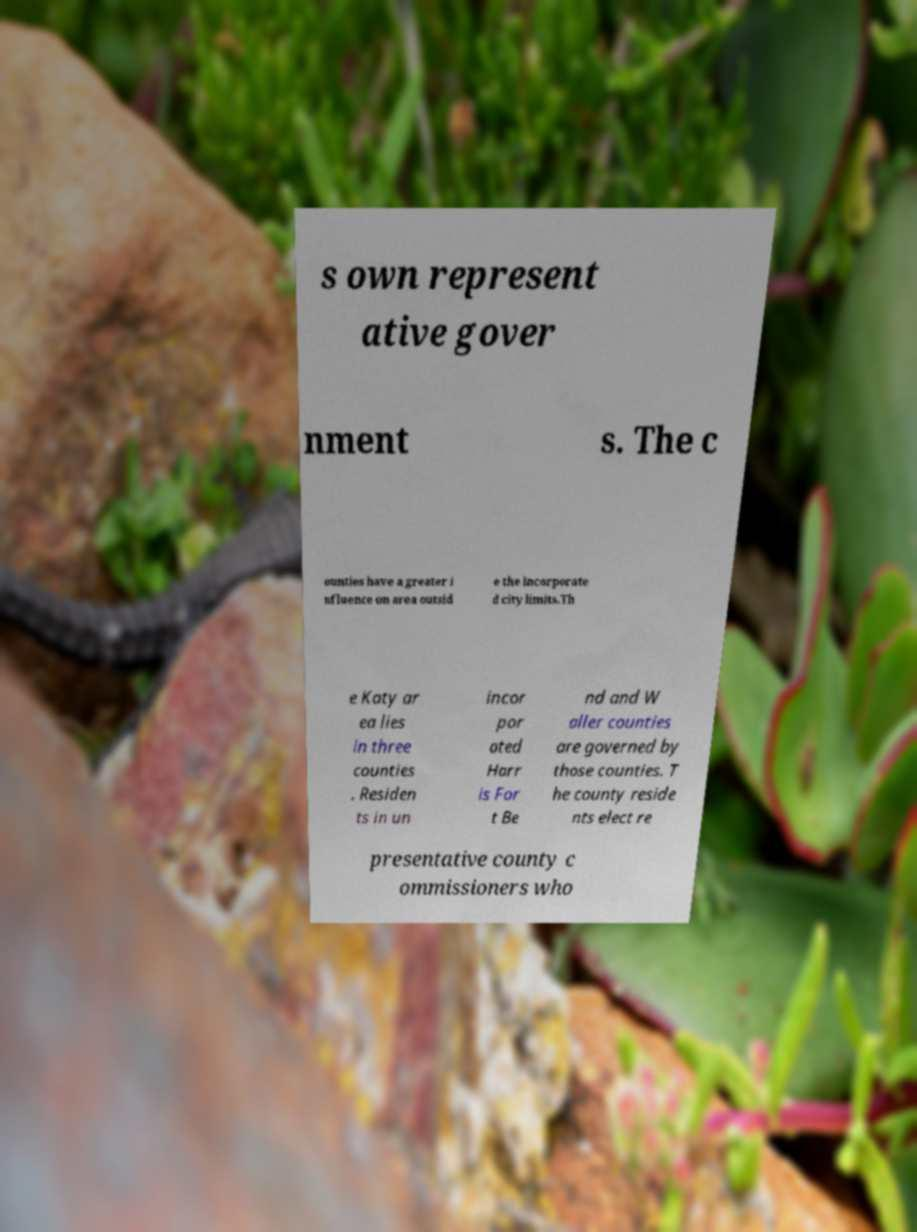Can you read and provide the text displayed in the image?This photo seems to have some interesting text. Can you extract and type it out for me? s own represent ative gover nment s. The c ounties have a greater i nfluence on area outsid e the incorporate d city limits.Th e Katy ar ea lies in three counties . Residen ts in un incor por ated Harr is For t Be nd and W aller counties are governed by those counties. T he county reside nts elect re presentative county c ommissioners who 